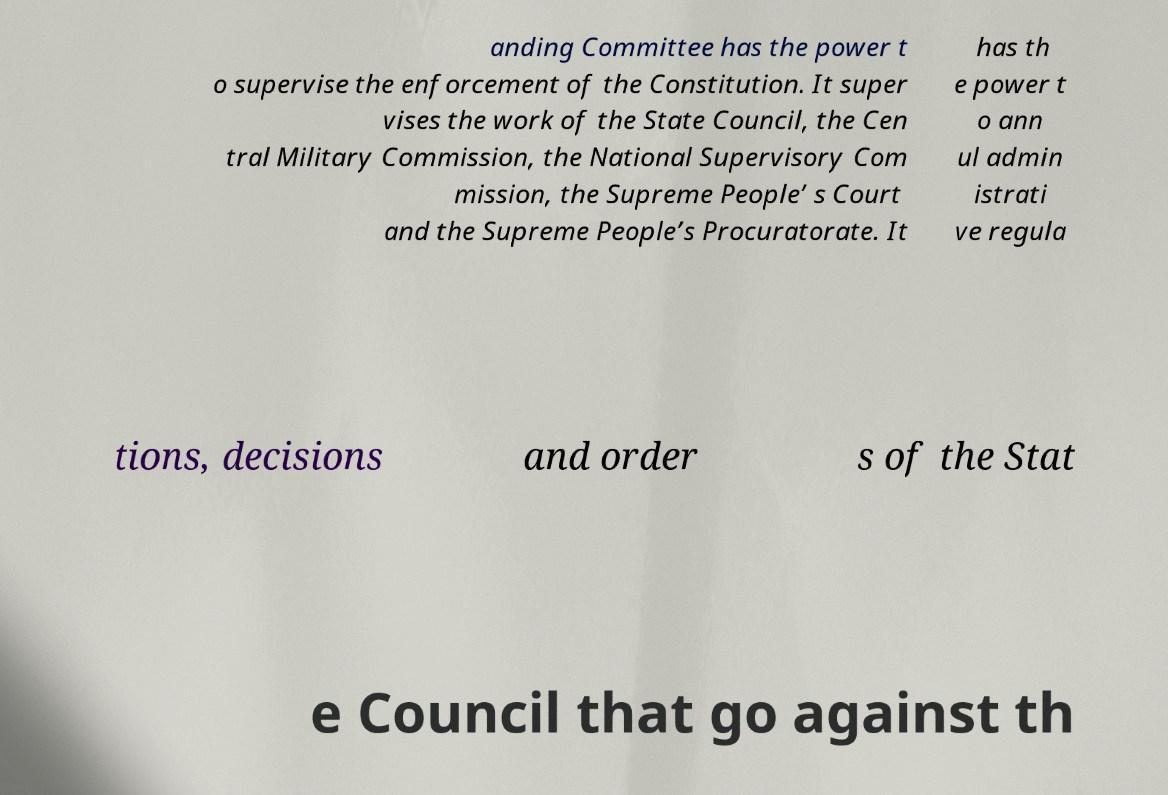What messages or text are displayed in this image? I need them in a readable, typed format. anding Committee has the power t o supervise the enforcement of the Constitution. It super vises the work of the State Council, the Cen tral Military Commission, the National Supervisory Com mission, the Supreme People’ s Court and the Supreme People’s Procuratorate. It has th e power t o ann ul admin istrati ve regula tions, decisions and order s of the Stat e Council that go against th 